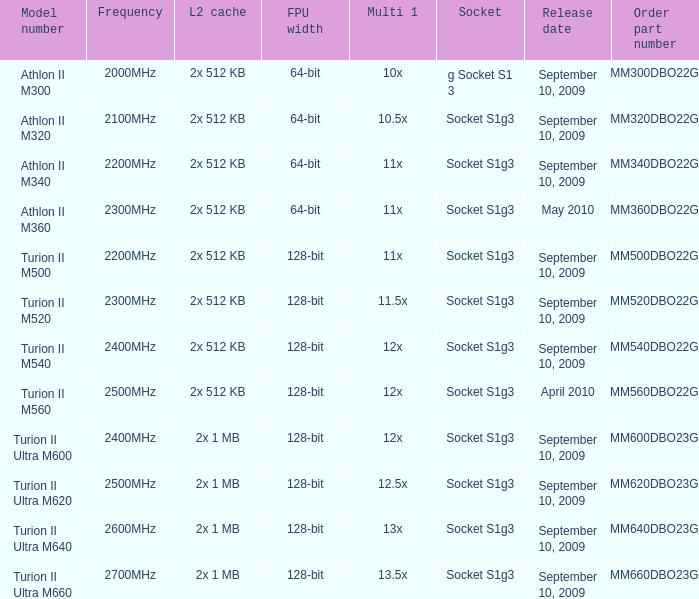What is the socket with a purchase part number of amm300dbo22gq and a september 10, 2009 launch date? G socket s1 3. 